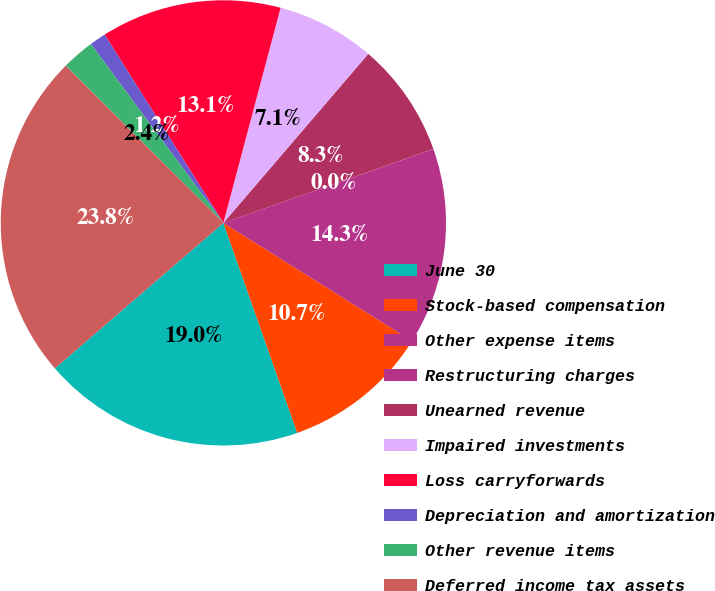<chart> <loc_0><loc_0><loc_500><loc_500><pie_chart><fcel>June 30<fcel>Stock-based compensation<fcel>Other expense items<fcel>Restructuring charges<fcel>Unearned revenue<fcel>Impaired investments<fcel>Loss carryforwards<fcel>Depreciation and amortization<fcel>Other revenue items<fcel>Deferred income tax assets<nl><fcel>19.04%<fcel>10.71%<fcel>14.28%<fcel>0.01%<fcel>8.33%<fcel>7.14%<fcel>13.09%<fcel>1.19%<fcel>2.38%<fcel>23.8%<nl></chart> 